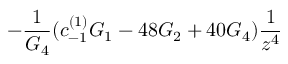<formula> <loc_0><loc_0><loc_500><loc_500>- \frac { 1 } { G _ { 4 } } ( c _ { - 1 } ^ { ( 1 ) } G _ { 1 } - 4 8 G _ { 2 } + 4 0 G _ { 4 } ) \frac { 1 } { z ^ { 4 } }</formula> 